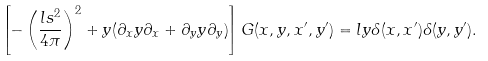<formula> <loc_0><loc_0><loc_500><loc_500>\left [ - \left ( \frac { l s ^ { 2 } } { 4 \pi } \right ) ^ { 2 } + y ( \partial _ { x } y \partial _ { x } + \partial _ { y } y \partial _ { y } ) \right ] G ( x , y , x ^ { \prime } , y ^ { \prime } ) = l y \delta ( x , x ^ { \prime } ) \delta ( y , y ^ { \prime } ) .</formula> 